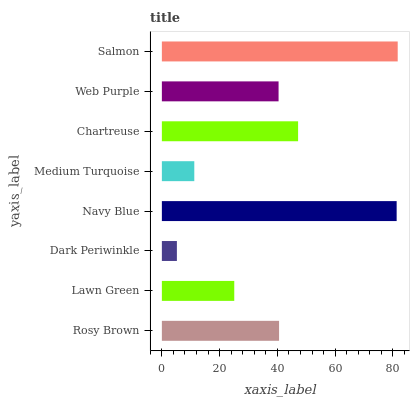Is Dark Periwinkle the minimum?
Answer yes or no. Yes. Is Salmon the maximum?
Answer yes or no. Yes. Is Lawn Green the minimum?
Answer yes or no. No. Is Lawn Green the maximum?
Answer yes or no. No. Is Rosy Brown greater than Lawn Green?
Answer yes or no. Yes. Is Lawn Green less than Rosy Brown?
Answer yes or no. Yes. Is Lawn Green greater than Rosy Brown?
Answer yes or no. No. Is Rosy Brown less than Lawn Green?
Answer yes or no. No. Is Rosy Brown the high median?
Answer yes or no. Yes. Is Web Purple the low median?
Answer yes or no. Yes. Is Chartreuse the high median?
Answer yes or no. No. Is Dark Periwinkle the low median?
Answer yes or no. No. 